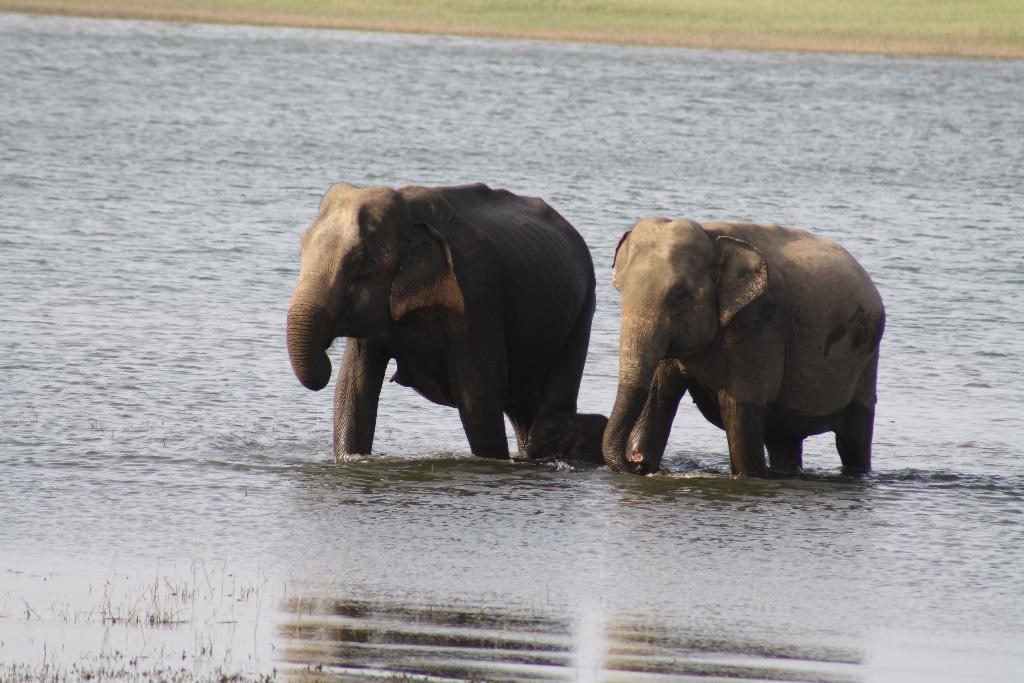What is visible in the image? There is water visible in the image. What animals are present in the image? There are 3 elephants in the center of the image. What type of vegetation can be seen in the background? There is grass in the background of the image. What type of trucks can be seen in the image? There are no trucks present in the image. What color is the sock on the elephant's foot in the image? There are no socks present in the image, as elephants do not wear socks. 